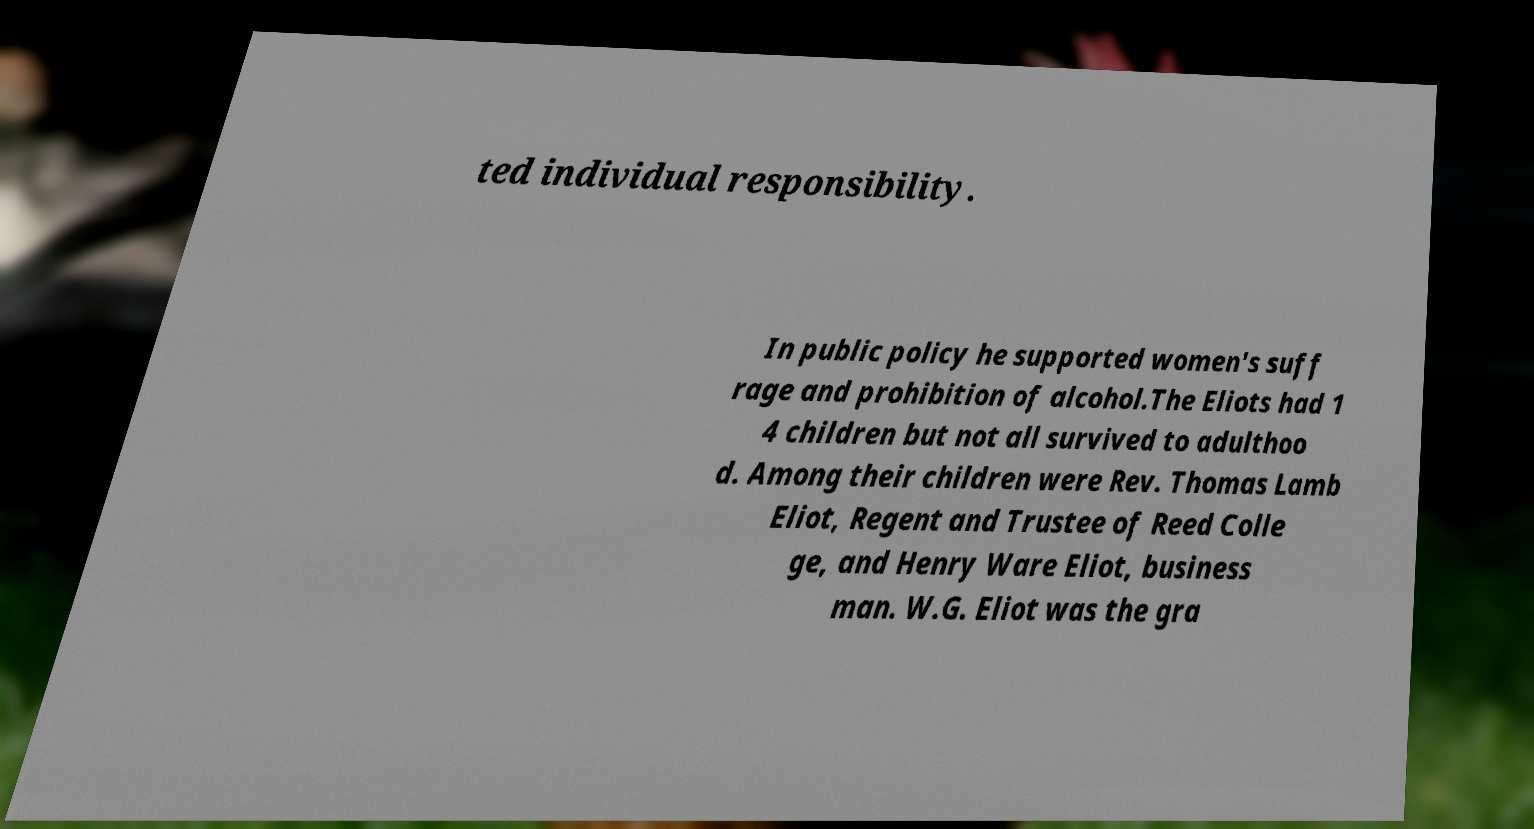There's text embedded in this image that I need extracted. Can you transcribe it verbatim? ted individual responsibility. In public policy he supported women's suff rage and prohibition of alcohol.The Eliots had 1 4 children but not all survived to adulthoo d. Among their children were Rev. Thomas Lamb Eliot, Regent and Trustee of Reed Colle ge, and Henry Ware Eliot, business man. W.G. Eliot was the gra 